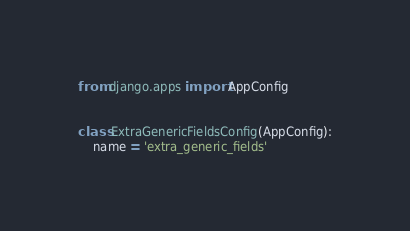<code> <loc_0><loc_0><loc_500><loc_500><_Python_>from django.apps import AppConfig


class ExtraGenericFieldsConfig(AppConfig):
    name = 'extra_generic_fields'
</code> 